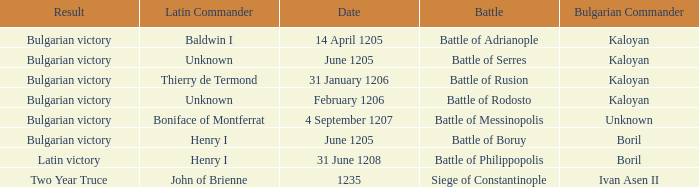Who is the Latin Commander of the Siege of Constantinople? John of Brienne. 